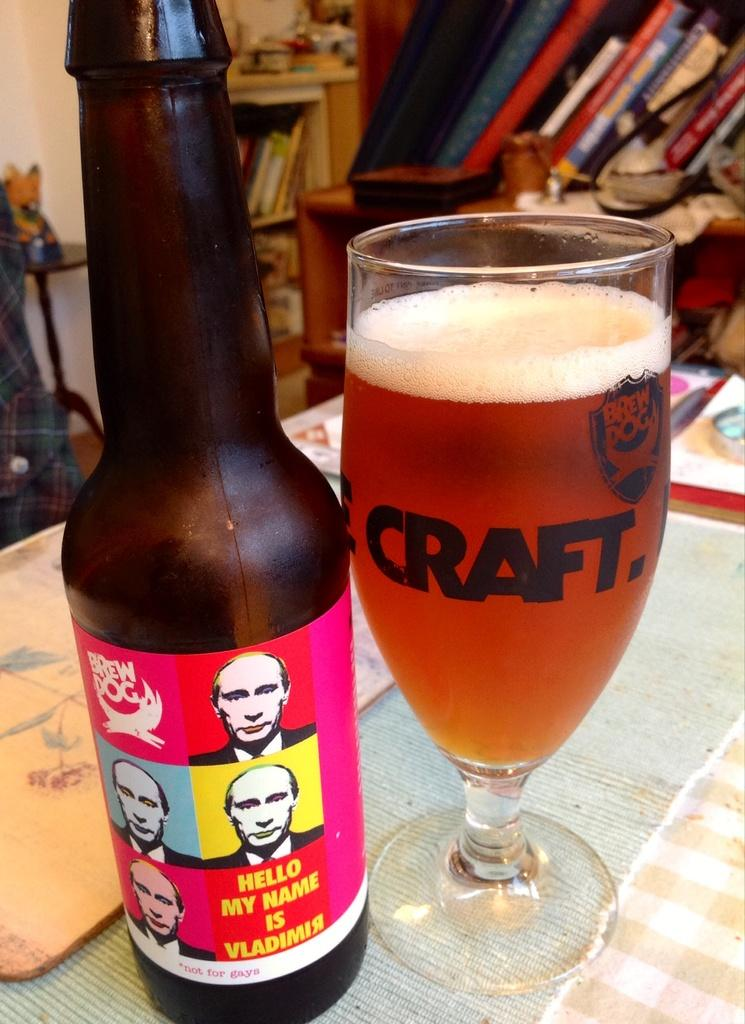<image>
Present a compact description of the photo's key features. A brown beer bottle with brew dog and five pictures of Putin with the words hello my name is Vladimir under them and a glass full of beer beside it. 